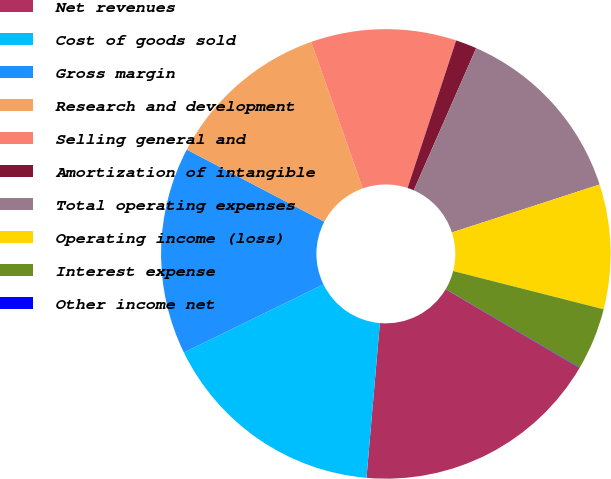<chart> <loc_0><loc_0><loc_500><loc_500><pie_chart><fcel>Net revenues<fcel>Cost of goods sold<fcel>Gross margin<fcel>Research and development<fcel>Selling general and<fcel>Amortization of intangible<fcel>Total operating expenses<fcel>Operating income (loss)<fcel>Interest expense<fcel>Other income net<nl><fcel>17.89%<fcel>16.4%<fcel>14.91%<fcel>11.93%<fcel>10.45%<fcel>1.52%<fcel>13.42%<fcel>8.96%<fcel>4.49%<fcel>0.03%<nl></chart> 